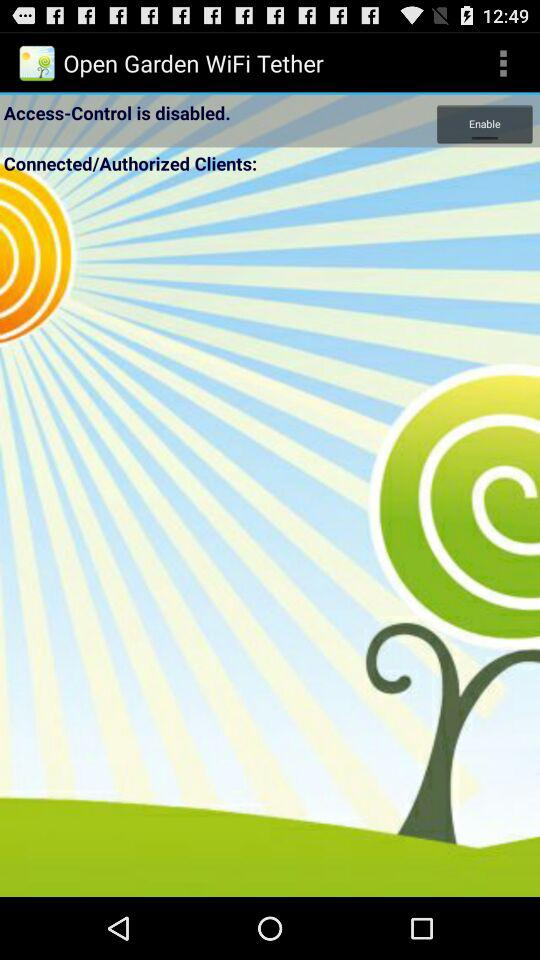What is the application name? The application name is "Open Garden WiFi Tether". 